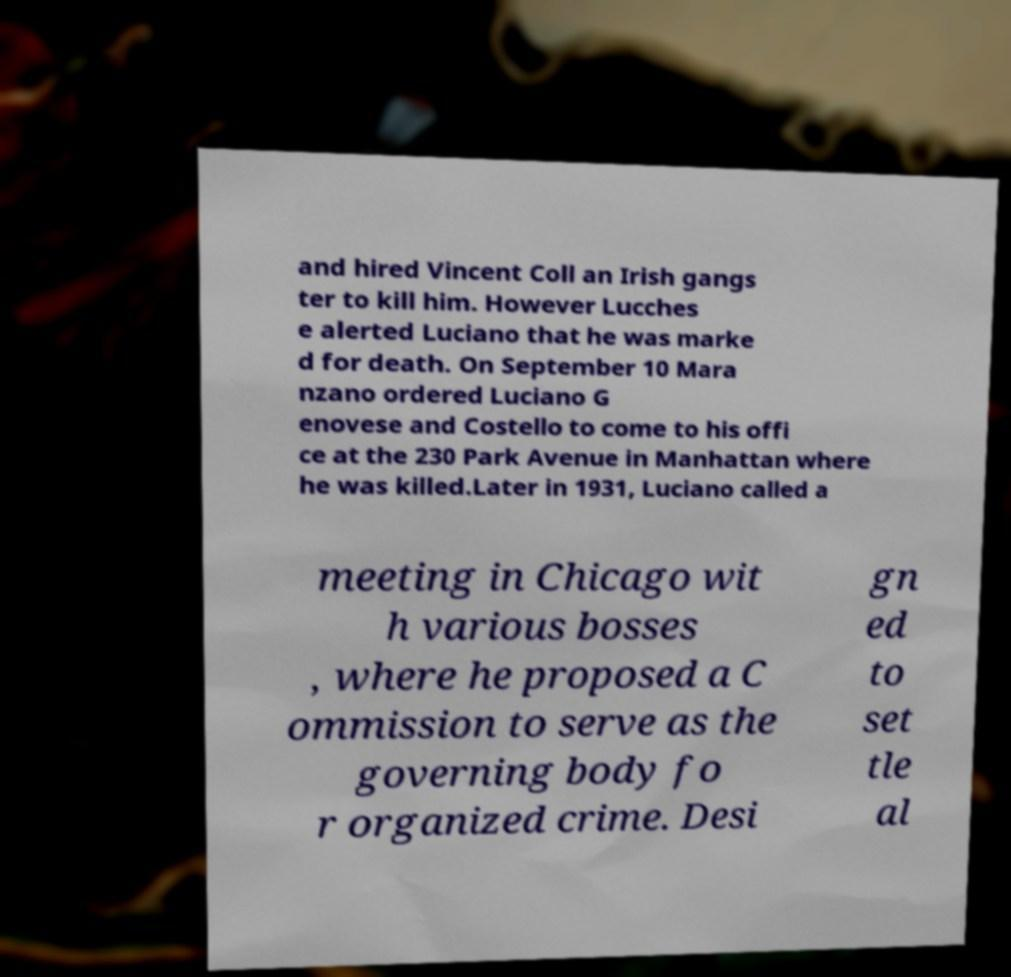Can you read and provide the text displayed in the image?This photo seems to have some interesting text. Can you extract and type it out for me? and hired Vincent Coll an Irish gangs ter to kill him. However Lucches e alerted Luciano that he was marke d for death. On September 10 Mara nzano ordered Luciano G enovese and Costello to come to his offi ce at the 230 Park Avenue in Manhattan where he was killed.Later in 1931, Luciano called a meeting in Chicago wit h various bosses , where he proposed a C ommission to serve as the governing body fo r organized crime. Desi gn ed to set tle al 